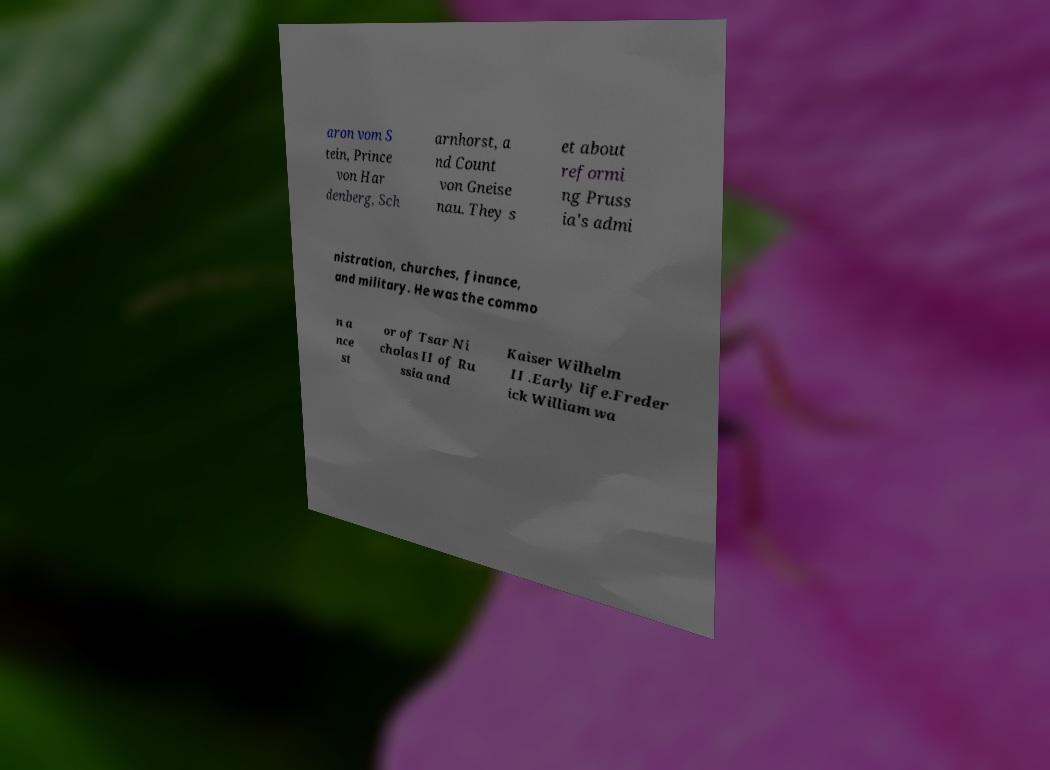Please read and relay the text visible in this image. What does it say? aron vom S tein, Prince von Har denberg, Sch arnhorst, a nd Count von Gneise nau. They s et about reformi ng Pruss ia's admi nistration, churches, finance, and military. He was the commo n a nce st or of Tsar Ni cholas II of Ru ssia and Kaiser Wilhelm II .Early life.Freder ick William wa 